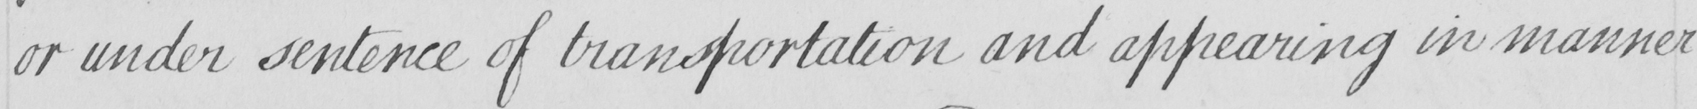Please transcribe the handwritten text in this image. or under sentence of transportation and appearing in manner 